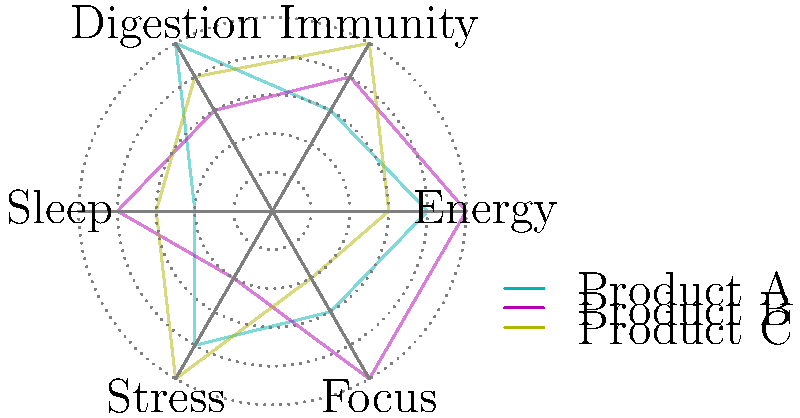Based on the radar chart comparing the efficacy of different wellness products across multiple health metrics, which product shows the highest overall performance across all metrics combined, and what strategic implications does this have for marketing the product line? To determine the highest overall performance and its strategic implications, we need to follow these steps:

1. Analyze each product's performance across all metrics:
   Product A (Cyan): Energy (4), Immunity (3), Digestion (5), Sleep (2), Stress (4), Focus (3)
   Product B (Magenta): Energy (5), Immunity (4), Digestion (3), Sleep (4), Stress (2), Focus (5)
   Product C (Yellow): Energy (3), Immunity (5), Digestion (4), Sleep (3), Stress (5), Focus (2)

2. Calculate the total score for each product:
   Product A: 4 + 3 + 5 + 2 + 4 + 3 = 21
   Product B: 5 + 4 + 3 + 4 + 2 + 5 = 23
   Product C: 3 + 5 + 4 + 3 + 5 + 2 = 22

3. Identify the highest overall performance:
   Product B has the highest total score of 23, indicating the best overall performance.

4. Analyze Product B's strengths and weaknesses:
   Strengths: Energy (5), Immunity (4), Sleep (4), Focus (5)
   Weaknesses: Digestion (3), Stress (2)

5. Consider strategic implications for marketing:
   a) Position Product B as an all-rounder wellness solution, emphasizing its balanced performance across multiple health metrics.
   b) Highlight Product B's superior performance in Energy and Focus, which are highly valued in today's fast-paced society.
   c) Create targeted marketing campaigns for specific consumer segments, such as professionals seeking improved energy and focus.
   d) Develop complementary products or bundles to address Product B's weaknesses in Digestion and Stress management.
   e) Use the strengths of Products A (Digestion) and C (Immunity, Stress) to create a comprehensive wellness package for consumers seeking targeted benefits.
   f) Implement a differentiated pricing strategy based on the overall performance and specific strengths of each product.
Answer: Product B shows the highest overall performance. Strategic implications include positioning it as an all-rounder wellness solution, emphasizing Energy and Focus benefits, targeting specific consumer segments, addressing weaknesses through complementary products, and implementing a differentiated pricing strategy. 